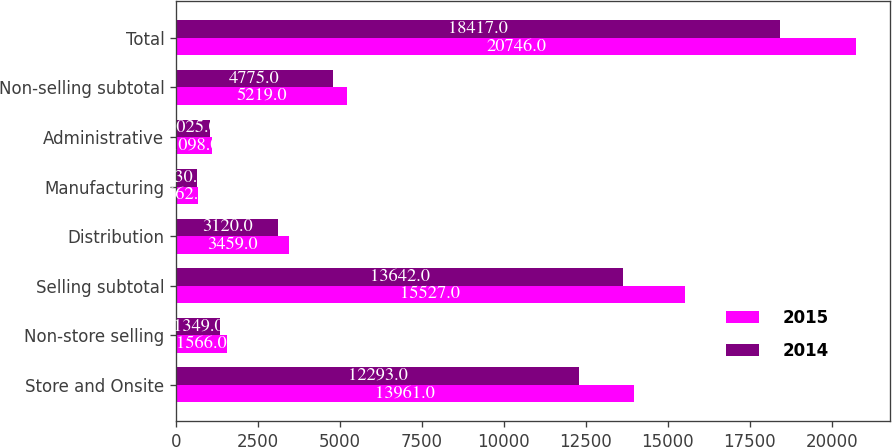Convert chart to OTSL. <chart><loc_0><loc_0><loc_500><loc_500><stacked_bar_chart><ecel><fcel>Store and Onsite<fcel>Non-store selling<fcel>Selling subtotal<fcel>Distribution<fcel>Manufacturing<fcel>Administrative<fcel>Non-selling subtotal<fcel>Total<nl><fcel>2015<fcel>13961<fcel>1566<fcel>15527<fcel>3459<fcel>662<fcel>1098<fcel>5219<fcel>20746<nl><fcel>2014<fcel>12293<fcel>1349<fcel>13642<fcel>3120<fcel>630<fcel>1025<fcel>4775<fcel>18417<nl></chart> 